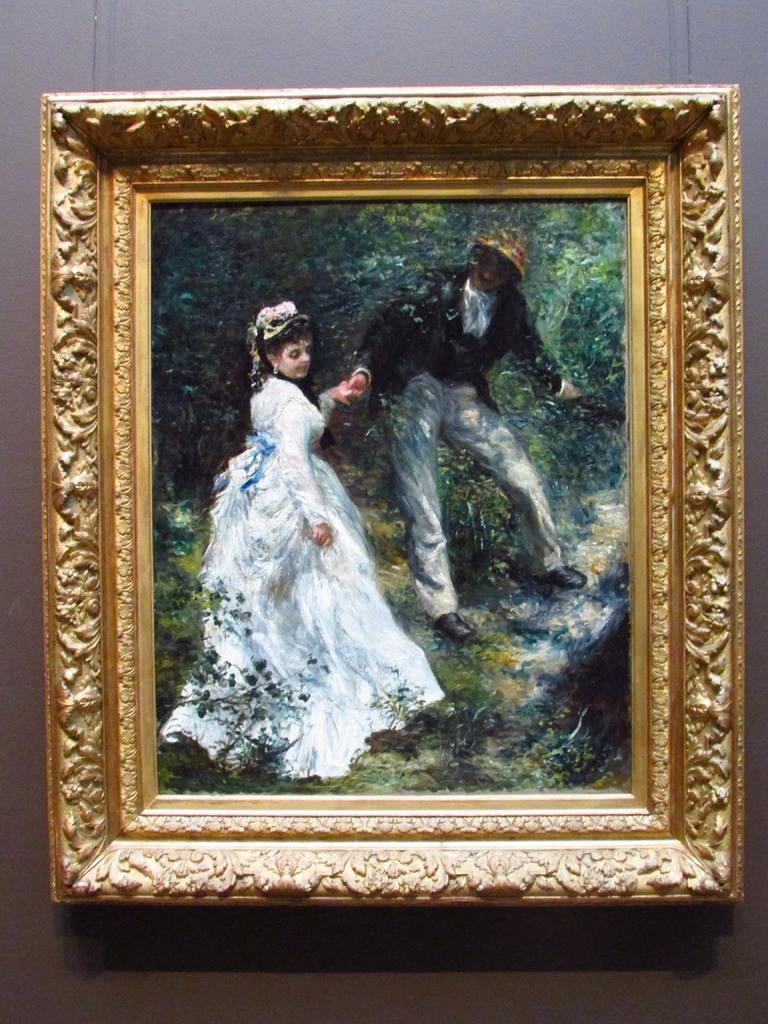What is hanging on the wall in the image? There is a frame on the wall in the image. What is inside the frame? The frame contains a painting. What is the subject of the painting? The painting depicts a man and a woman. What color is the background in the image? The background in the image is green. Can you see a basketball being played in the image? No, there is no basketball or any indication of a game being played in the image. Is there a stick visible in the painting? No, there is no stick present in the painting; it depicts a man and a woman. 